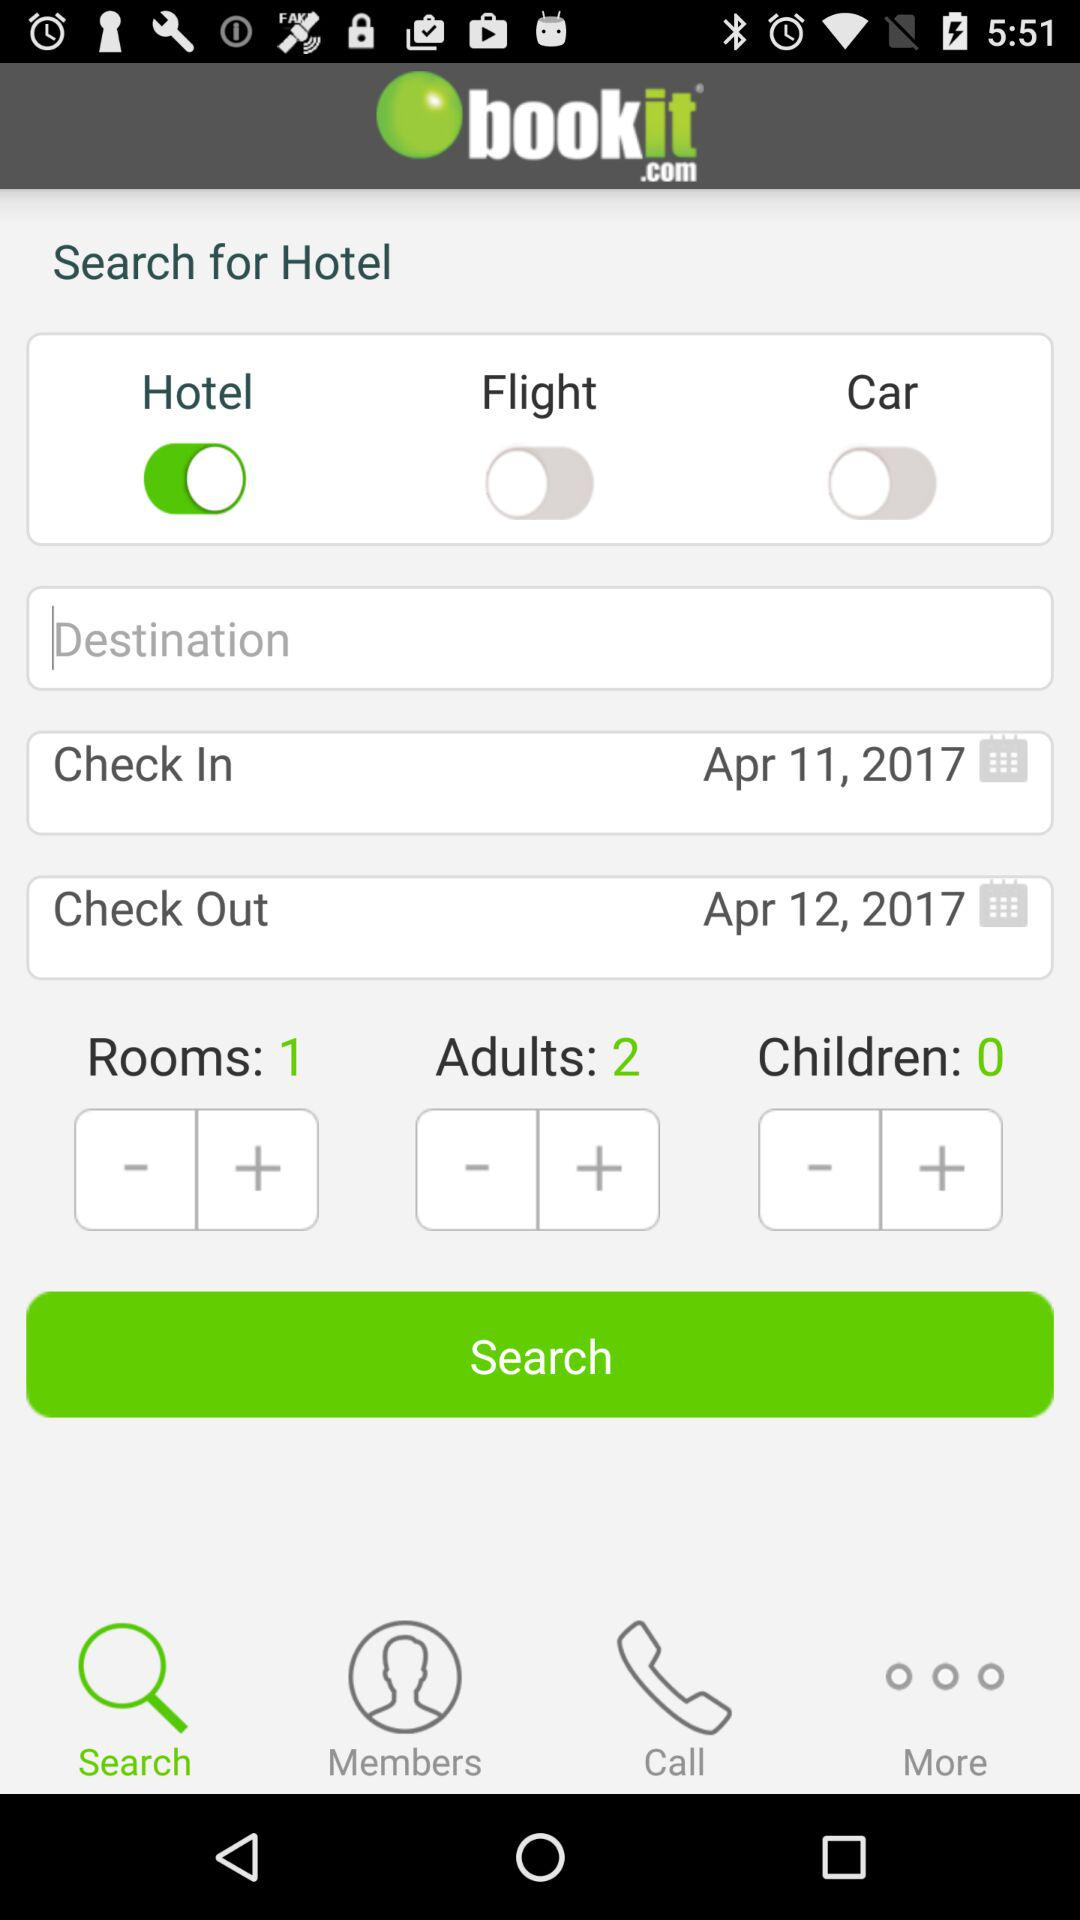How many more adults are there than children?
Answer the question using a single word or phrase. 2 